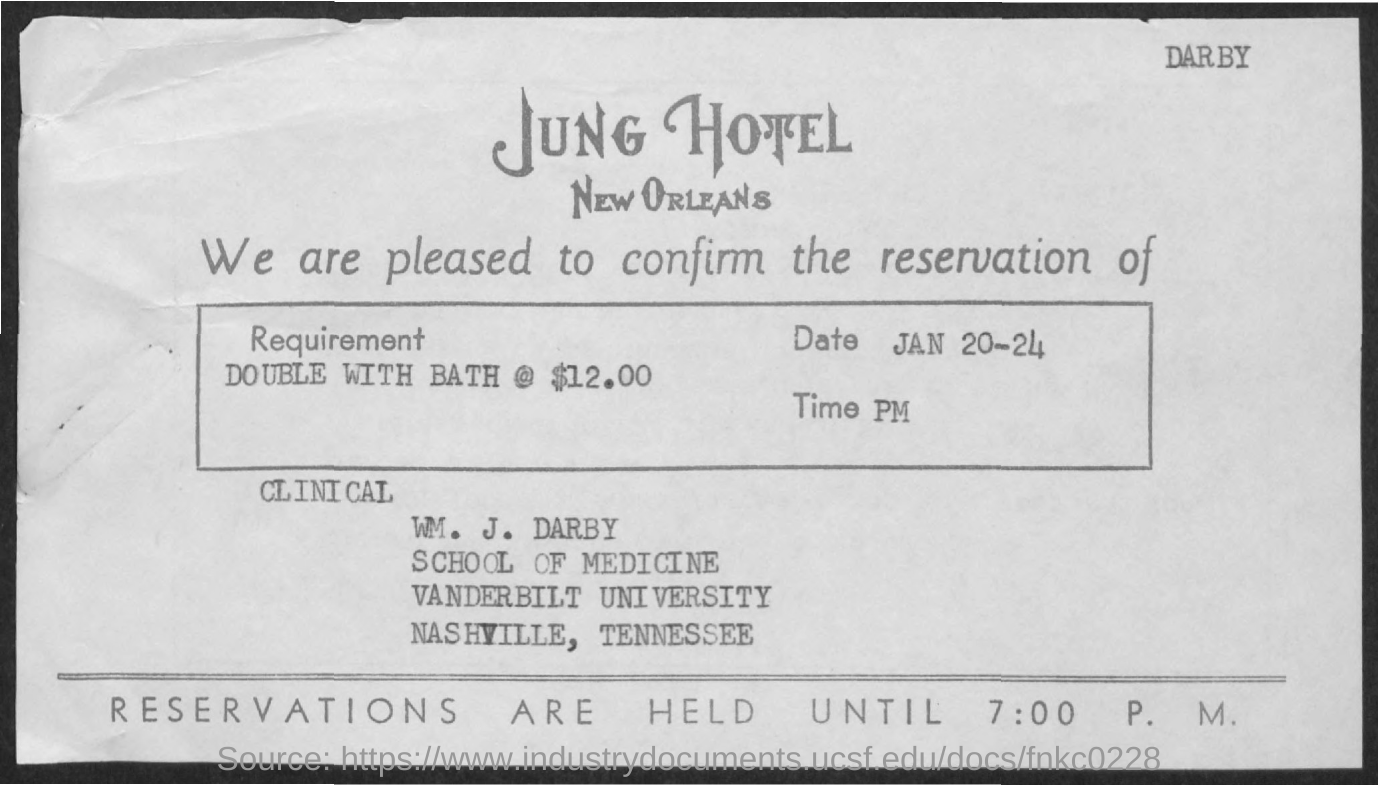What is the requirement?
Your answer should be compact. Double with bath @ $12.00. What is the Date?
Your response must be concise. Jan 20-24. Where is the reservation made?
Give a very brief answer. Jung Hotel. To Whom is this letter addressed to?
Your response must be concise. WM. J. Darby. What is the time?
Provide a short and direct response. PM. Till what time are the reservations held?
Give a very brief answer. 7:00 P.M. 